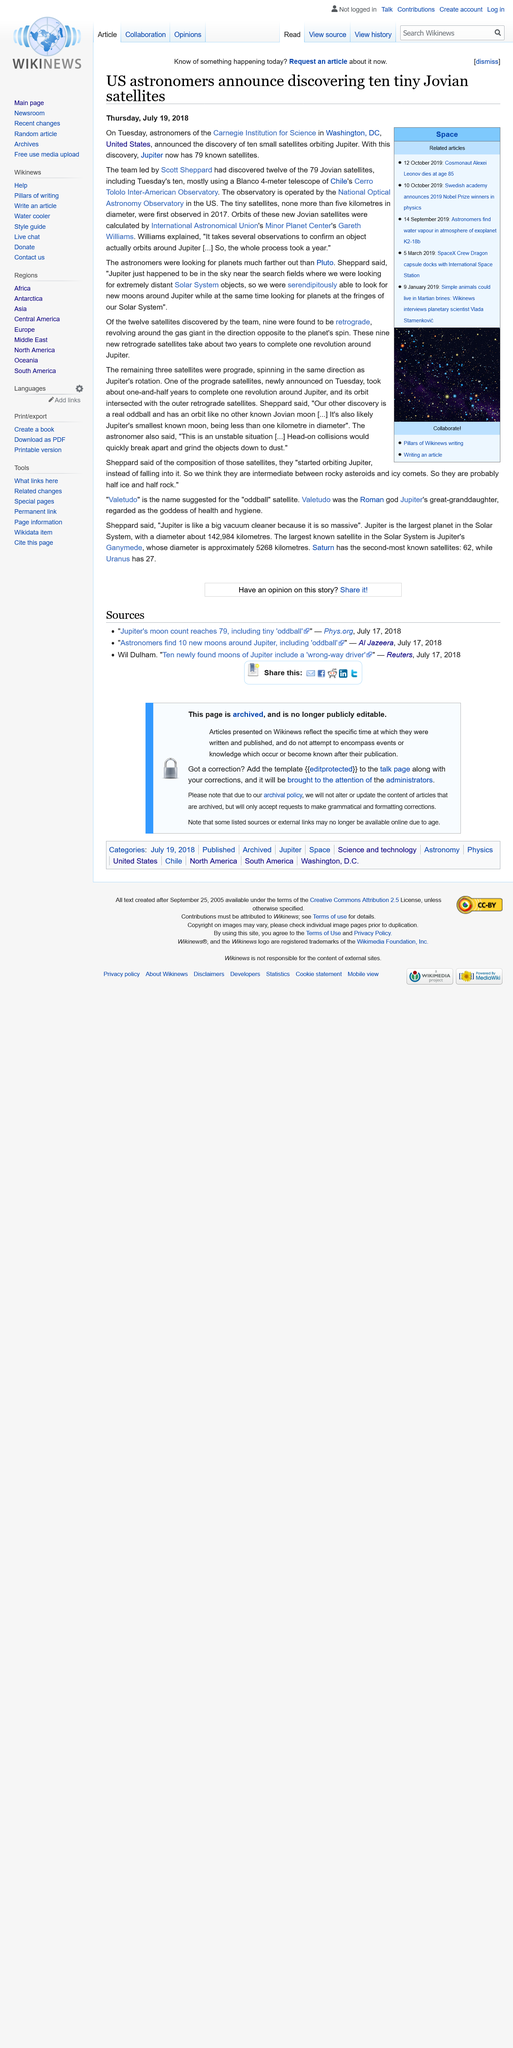Specify some key components in this picture. Jupiter has 79 known satellites, providing valuable insights into the planet's formation and evolution. The Cerro Totolo Inter-American Observatory is located in Chile, a country known for its rich astronomical heritage and stargazing opportunities. The Carnegie Institution for Science is located in the city of Washington, D.C. in the United States. 